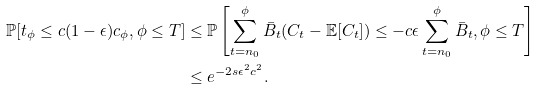<formula> <loc_0><loc_0><loc_500><loc_500>\mathbb { P } [ t _ { \phi } \leq c ( 1 - \epsilon ) c _ { \phi } , \phi \leq T ] & \leq \mathbb { P } \left [ \sum _ { t = n _ { 0 } } ^ { \phi } \bar { B } _ { t } ( C _ { t } - \mathbb { E } [ C _ { t } ] ) \leq - c \epsilon \sum _ { t = n _ { 0 } } ^ { \phi } \bar { B } _ { t } , \phi \leq T \right ] \\ & \leq e ^ { - 2 s \epsilon ^ { 2 } c ^ { 2 } } .</formula> 